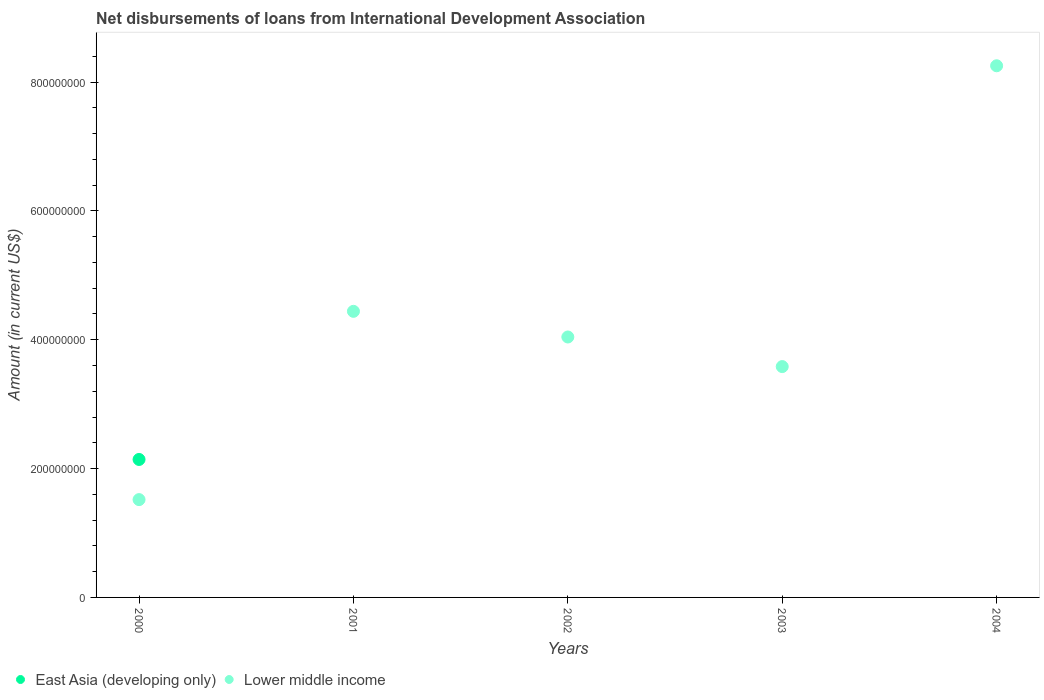How many different coloured dotlines are there?
Give a very brief answer. 2. What is the amount of loans disbursed in Lower middle income in 2001?
Provide a short and direct response. 4.44e+08. Across all years, what is the maximum amount of loans disbursed in Lower middle income?
Your answer should be compact. 8.25e+08. Across all years, what is the minimum amount of loans disbursed in Lower middle income?
Make the answer very short. 1.52e+08. What is the total amount of loans disbursed in East Asia (developing only) in the graph?
Offer a terse response. 2.14e+08. What is the difference between the amount of loans disbursed in Lower middle income in 2002 and that in 2004?
Provide a succinct answer. -4.21e+08. What is the difference between the amount of loans disbursed in East Asia (developing only) in 2001 and the amount of loans disbursed in Lower middle income in 2000?
Provide a short and direct response. -1.52e+08. What is the average amount of loans disbursed in Lower middle income per year?
Ensure brevity in your answer.  4.37e+08. In the year 2000, what is the difference between the amount of loans disbursed in East Asia (developing only) and amount of loans disbursed in Lower middle income?
Keep it short and to the point. 6.23e+07. What is the ratio of the amount of loans disbursed in Lower middle income in 2001 to that in 2004?
Give a very brief answer. 0.54. What is the difference between the highest and the second highest amount of loans disbursed in Lower middle income?
Make the answer very short. 3.81e+08. What is the difference between the highest and the lowest amount of loans disbursed in East Asia (developing only)?
Your answer should be very brief. 2.14e+08. In how many years, is the amount of loans disbursed in East Asia (developing only) greater than the average amount of loans disbursed in East Asia (developing only) taken over all years?
Give a very brief answer. 1. Does the amount of loans disbursed in East Asia (developing only) monotonically increase over the years?
Your response must be concise. No. How many dotlines are there?
Offer a very short reply. 2. What is the difference between two consecutive major ticks on the Y-axis?
Offer a terse response. 2.00e+08. Does the graph contain grids?
Give a very brief answer. No. Where does the legend appear in the graph?
Offer a terse response. Bottom left. How are the legend labels stacked?
Provide a short and direct response. Horizontal. What is the title of the graph?
Your answer should be very brief. Net disbursements of loans from International Development Association. What is the label or title of the X-axis?
Ensure brevity in your answer.  Years. What is the label or title of the Y-axis?
Keep it short and to the point. Amount (in current US$). What is the Amount (in current US$) of East Asia (developing only) in 2000?
Offer a very short reply. 2.14e+08. What is the Amount (in current US$) of Lower middle income in 2000?
Your answer should be compact. 1.52e+08. What is the Amount (in current US$) in Lower middle income in 2001?
Offer a very short reply. 4.44e+08. What is the Amount (in current US$) of East Asia (developing only) in 2002?
Give a very brief answer. 0. What is the Amount (in current US$) in Lower middle income in 2002?
Provide a succinct answer. 4.04e+08. What is the Amount (in current US$) in East Asia (developing only) in 2003?
Ensure brevity in your answer.  0. What is the Amount (in current US$) in Lower middle income in 2003?
Provide a short and direct response. 3.58e+08. What is the Amount (in current US$) in East Asia (developing only) in 2004?
Offer a terse response. 0. What is the Amount (in current US$) of Lower middle income in 2004?
Your answer should be compact. 8.25e+08. Across all years, what is the maximum Amount (in current US$) in East Asia (developing only)?
Your answer should be very brief. 2.14e+08. Across all years, what is the maximum Amount (in current US$) in Lower middle income?
Offer a very short reply. 8.25e+08. Across all years, what is the minimum Amount (in current US$) in East Asia (developing only)?
Your answer should be compact. 0. Across all years, what is the minimum Amount (in current US$) of Lower middle income?
Give a very brief answer. 1.52e+08. What is the total Amount (in current US$) in East Asia (developing only) in the graph?
Offer a very short reply. 2.14e+08. What is the total Amount (in current US$) in Lower middle income in the graph?
Make the answer very short. 2.18e+09. What is the difference between the Amount (in current US$) in Lower middle income in 2000 and that in 2001?
Provide a succinct answer. -2.92e+08. What is the difference between the Amount (in current US$) in Lower middle income in 2000 and that in 2002?
Offer a terse response. -2.52e+08. What is the difference between the Amount (in current US$) in Lower middle income in 2000 and that in 2003?
Your response must be concise. -2.07e+08. What is the difference between the Amount (in current US$) in Lower middle income in 2000 and that in 2004?
Make the answer very short. -6.73e+08. What is the difference between the Amount (in current US$) of Lower middle income in 2001 and that in 2002?
Your response must be concise. 3.98e+07. What is the difference between the Amount (in current US$) in Lower middle income in 2001 and that in 2003?
Keep it short and to the point. 8.58e+07. What is the difference between the Amount (in current US$) of Lower middle income in 2001 and that in 2004?
Offer a very short reply. -3.81e+08. What is the difference between the Amount (in current US$) of Lower middle income in 2002 and that in 2003?
Offer a terse response. 4.59e+07. What is the difference between the Amount (in current US$) in Lower middle income in 2002 and that in 2004?
Your response must be concise. -4.21e+08. What is the difference between the Amount (in current US$) of Lower middle income in 2003 and that in 2004?
Provide a short and direct response. -4.67e+08. What is the difference between the Amount (in current US$) in East Asia (developing only) in 2000 and the Amount (in current US$) in Lower middle income in 2001?
Provide a succinct answer. -2.30e+08. What is the difference between the Amount (in current US$) in East Asia (developing only) in 2000 and the Amount (in current US$) in Lower middle income in 2002?
Your answer should be very brief. -1.90e+08. What is the difference between the Amount (in current US$) of East Asia (developing only) in 2000 and the Amount (in current US$) of Lower middle income in 2003?
Your answer should be very brief. -1.44e+08. What is the difference between the Amount (in current US$) of East Asia (developing only) in 2000 and the Amount (in current US$) of Lower middle income in 2004?
Ensure brevity in your answer.  -6.11e+08. What is the average Amount (in current US$) in East Asia (developing only) per year?
Provide a short and direct response. 4.28e+07. What is the average Amount (in current US$) in Lower middle income per year?
Ensure brevity in your answer.  4.37e+08. In the year 2000, what is the difference between the Amount (in current US$) in East Asia (developing only) and Amount (in current US$) in Lower middle income?
Your answer should be very brief. 6.23e+07. What is the ratio of the Amount (in current US$) of Lower middle income in 2000 to that in 2001?
Offer a very short reply. 0.34. What is the ratio of the Amount (in current US$) of Lower middle income in 2000 to that in 2002?
Give a very brief answer. 0.38. What is the ratio of the Amount (in current US$) of Lower middle income in 2000 to that in 2003?
Your answer should be compact. 0.42. What is the ratio of the Amount (in current US$) in Lower middle income in 2000 to that in 2004?
Give a very brief answer. 0.18. What is the ratio of the Amount (in current US$) in Lower middle income in 2001 to that in 2002?
Give a very brief answer. 1.1. What is the ratio of the Amount (in current US$) of Lower middle income in 2001 to that in 2003?
Provide a short and direct response. 1.24. What is the ratio of the Amount (in current US$) of Lower middle income in 2001 to that in 2004?
Offer a terse response. 0.54. What is the ratio of the Amount (in current US$) in Lower middle income in 2002 to that in 2003?
Your response must be concise. 1.13. What is the ratio of the Amount (in current US$) in Lower middle income in 2002 to that in 2004?
Ensure brevity in your answer.  0.49. What is the ratio of the Amount (in current US$) in Lower middle income in 2003 to that in 2004?
Your answer should be compact. 0.43. What is the difference between the highest and the second highest Amount (in current US$) of Lower middle income?
Provide a succinct answer. 3.81e+08. What is the difference between the highest and the lowest Amount (in current US$) of East Asia (developing only)?
Your answer should be compact. 2.14e+08. What is the difference between the highest and the lowest Amount (in current US$) in Lower middle income?
Offer a very short reply. 6.73e+08. 